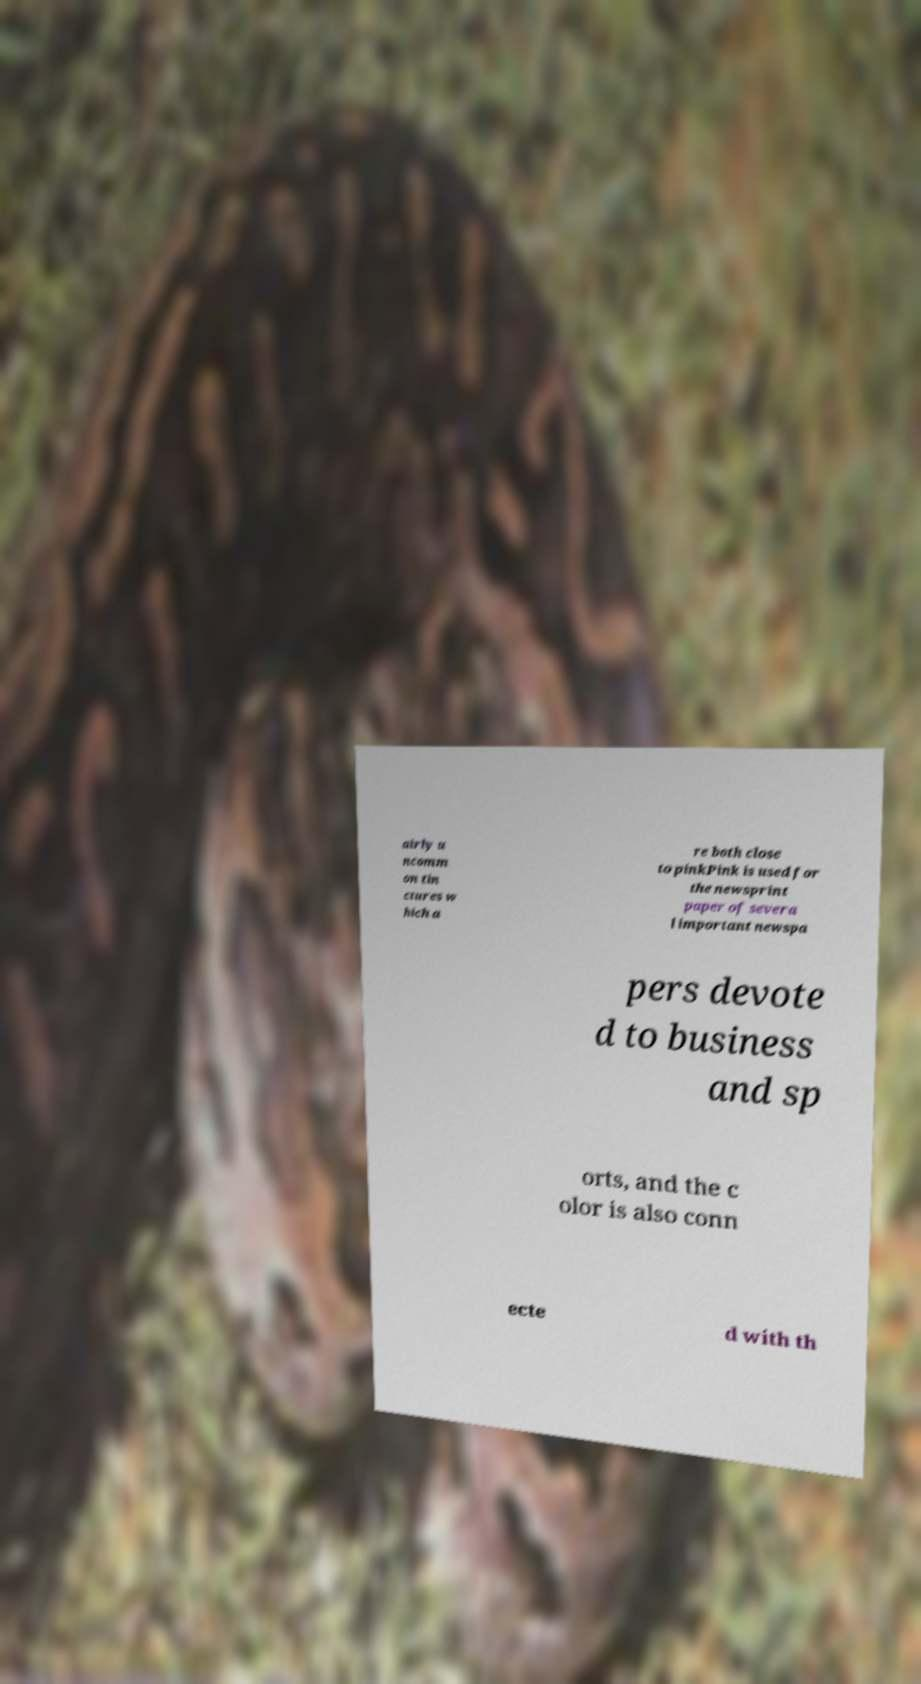For documentation purposes, I need the text within this image transcribed. Could you provide that? airly u ncomm on tin ctures w hich a re both close to pinkPink is used for the newsprint paper of severa l important newspa pers devote d to business and sp orts, and the c olor is also conn ecte d with th 